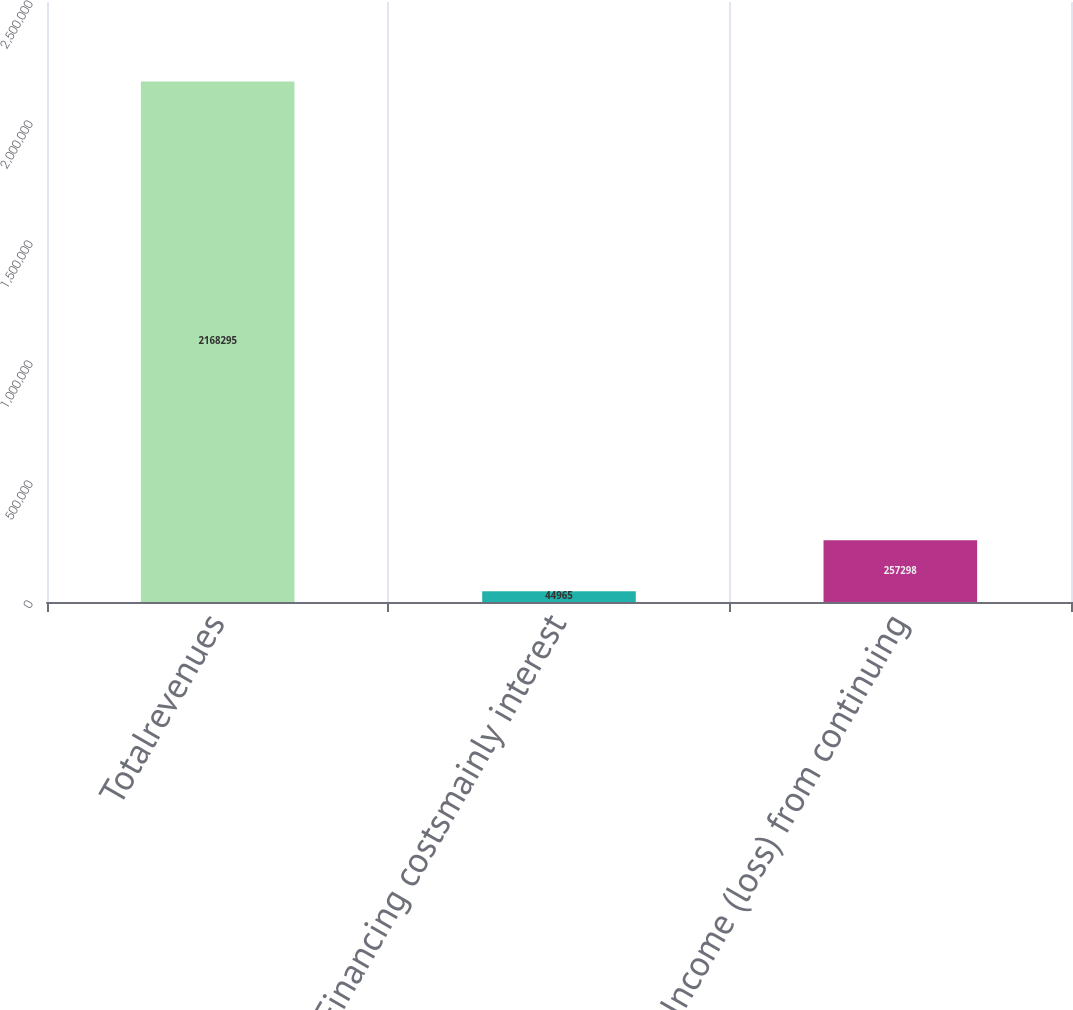Convert chart to OTSL. <chart><loc_0><loc_0><loc_500><loc_500><bar_chart><fcel>Totalrevenues<fcel>Financing costsmainly interest<fcel>Income (loss) from continuing<nl><fcel>2.1683e+06<fcel>44965<fcel>257298<nl></chart> 